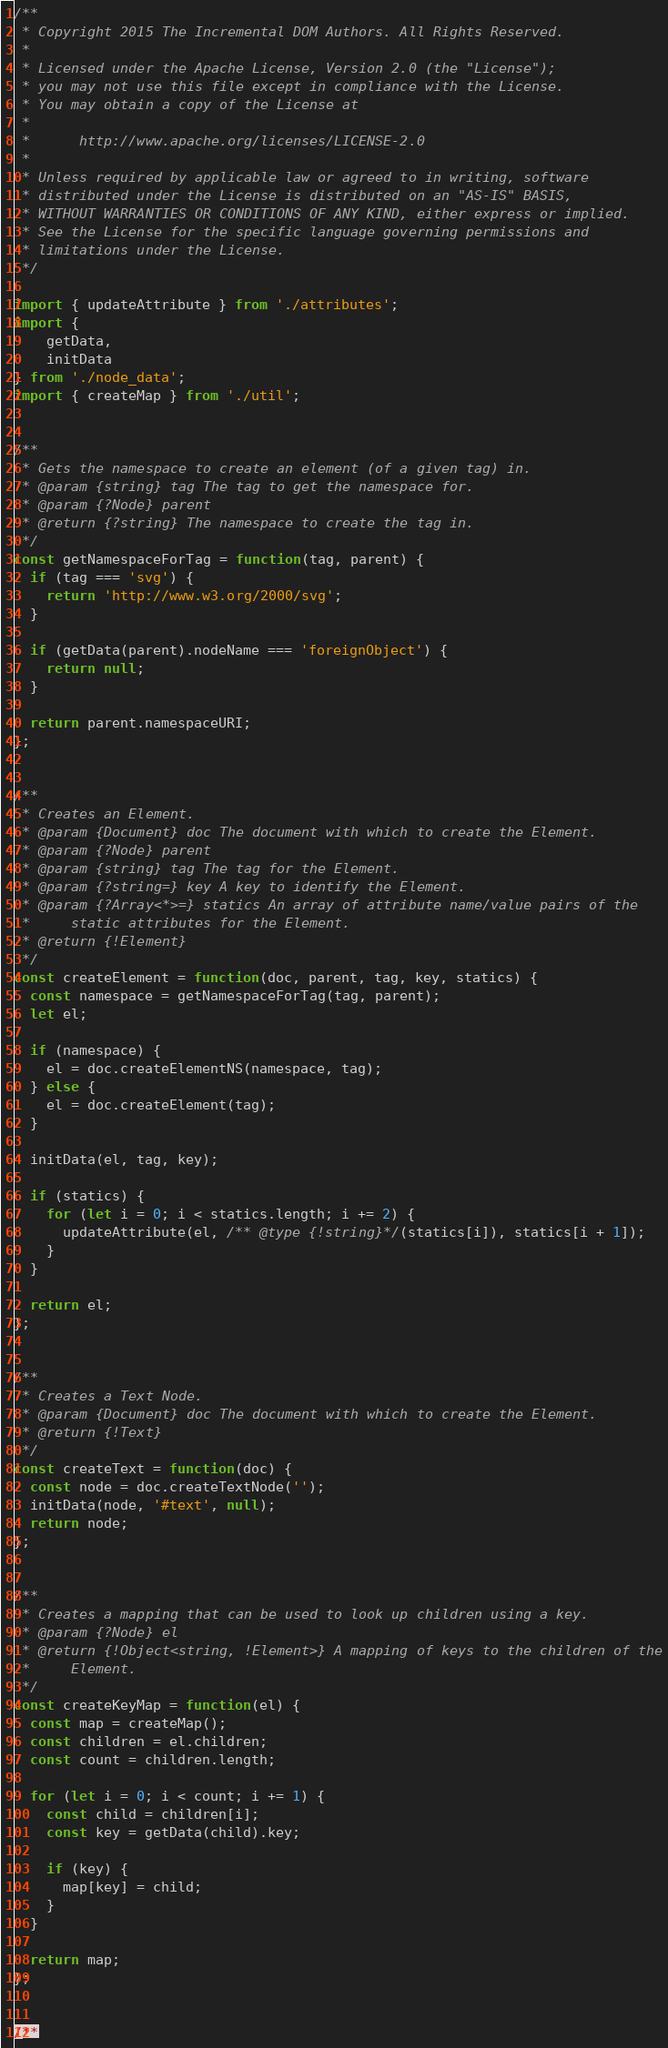Convert code to text. <code><loc_0><loc_0><loc_500><loc_500><_JavaScript_>/**
 * Copyright 2015 The Incremental DOM Authors. All Rights Reserved.
 *
 * Licensed under the Apache License, Version 2.0 (the "License");
 * you may not use this file except in compliance with the License.
 * You may obtain a copy of the License at
 *
 *      http://www.apache.org/licenses/LICENSE-2.0
 *
 * Unless required by applicable law or agreed to in writing, software
 * distributed under the License is distributed on an "AS-IS" BASIS,
 * WITHOUT WARRANTIES OR CONDITIONS OF ANY KIND, either express or implied.
 * See the License for the specific language governing permissions and
 * limitations under the License.
 */

import { updateAttribute } from './attributes';
import {
    getData,
    initData
} from './node_data';
import { createMap } from './util';


/**
 * Gets the namespace to create an element (of a given tag) in.
 * @param {string} tag The tag to get the namespace for.
 * @param {?Node} parent
 * @return {?string} The namespace to create the tag in.
 */
const getNamespaceForTag = function(tag, parent) {
  if (tag === 'svg') {
    return 'http://www.w3.org/2000/svg';
  }

  if (getData(parent).nodeName === 'foreignObject') {
    return null;
  }

  return parent.namespaceURI;
};


/**
 * Creates an Element.
 * @param {Document} doc The document with which to create the Element.
 * @param {?Node} parent
 * @param {string} tag The tag for the Element.
 * @param {?string=} key A key to identify the Element.
 * @param {?Array<*>=} statics An array of attribute name/value pairs of the
 *     static attributes for the Element.
 * @return {!Element}
 */
const createElement = function(doc, parent, tag, key, statics) {
  const namespace = getNamespaceForTag(tag, parent);
  let el;

  if (namespace) {
    el = doc.createElementNS(namespace, tag);
  } else {
    el = doc.createElement(tag);
  }

  initData(el, tag, key);

  if (statics) {
    for (let i = 0; i < statics.length; i += 2) {
      updateAttribute(el, /** @type {!string}*/(statics[i]), statics[i + 1]);
    }
  }

  return el;
};


/**
 * Creates a Text Node.
 * @param {Document} doc The document with which to create the Element.
 * @return {!Text}
 */
const createText = function(doc) {
  const node = doc.createTextNode('');
  initData(node, '#text', null);
  return node;
};


/**
 * Creates a mapping that can be used to look up children using a key.
 * @param {?Node} el
 * @return {!Object<string, !Element>} A mapping of keys to the children of the
 *     Element.
 */
const createKeyMap = function(el) {
  const map = createMap();
  const children = el.children;
  const count = children.length;

  for (let i = 0; i < count; i += 1) {
    const child = children[i];
    const key = getData(child).key;

    if (key) {
      map[key] = child;
    }
  }

  return map;
};


/**</code> 